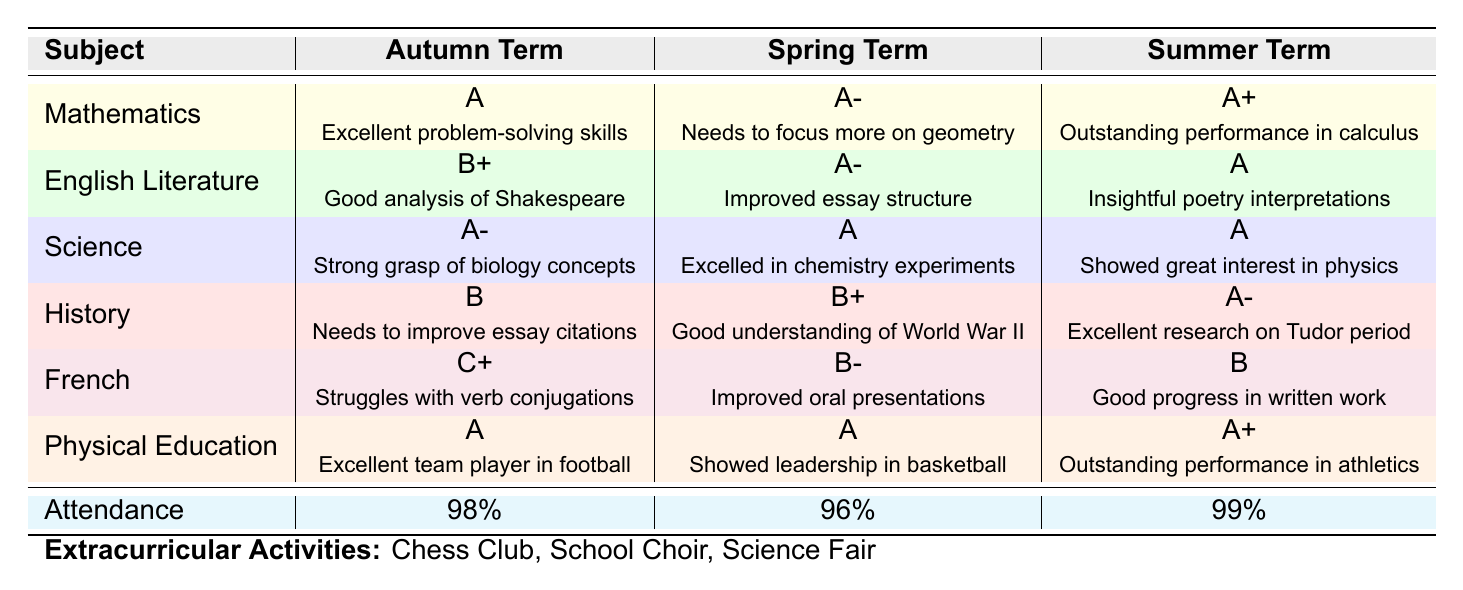What was Anthony's grade in Mathematics during the Summer Term? According to the table, Anthony earned an A+ in Mathematics for the Summer Term.
Answer: A+ How did Anthony's attendance change from the Autumn Term to the Spring Term? In the Autumn Term, his attendance was 98%, and in the Spring Term, it dropped to 96%. The change is a decrease of 2%.
Answer: Decreased by 2% Did Anthony improve in English Literature from the Autumn Term to the Summer Term? His grades in English Literature were B+ in the Autumn Term, A- in the Spring Term, and A in the Summer Term, indicating steady improvement over the terms.
Answer: Yes What was the average attendance percentage over the three terms? To find the average attendance, add the three percentages: 98 + 96 + 99 = 293, then divide by 3. So, 293 / 3 = 97.67%.
Answer: 97.67% What grade did Anthony receive in French during the Autumn Term, and what was the teacher's comment? In the Autumn Term, Anthony received a C+ in French, and the teacher commented on his struggles with verb conjugations.
Answer: C+, struggles with verb conjugations Which subject saw the most improvement in grades from the Autumn Term to the Summer Term? The most improvement can be seen in French, where the grade progressed from C+ to B over the terms. This indicates significant improvement compared to other subjects.
Answer: French Which term had the highest attendance percentage? The attendance percentages were 98% for the Autumn Term, 96% for the Spring Term, and 99% for the Summer Term. The highest was in the Summer Term.
Answer: Summer Term Did Anthony's performance in Physical Education remain consistent across all three terms? Anthony received A grades in both the Autumn and Spring Terms and an A+ in the Summer Term. Although the final term shows a slight increase, the overall performance was consistently high.
Answer: Yes, consistent high performance How many extracurricular activities is Anthony involved in? The table lists three extracurricular activities: Chess Club, School Choir, and Science Fair.
Answer: Three activities What is the overall trend of Anthony's grades across all subjects from Autumn to Summer? The grades for most subjects improved, with a noticeable progression in Mathematics, English Literature, Science, and History. The trend indicates a positive overall performance development.
Answer: Overall improvement 